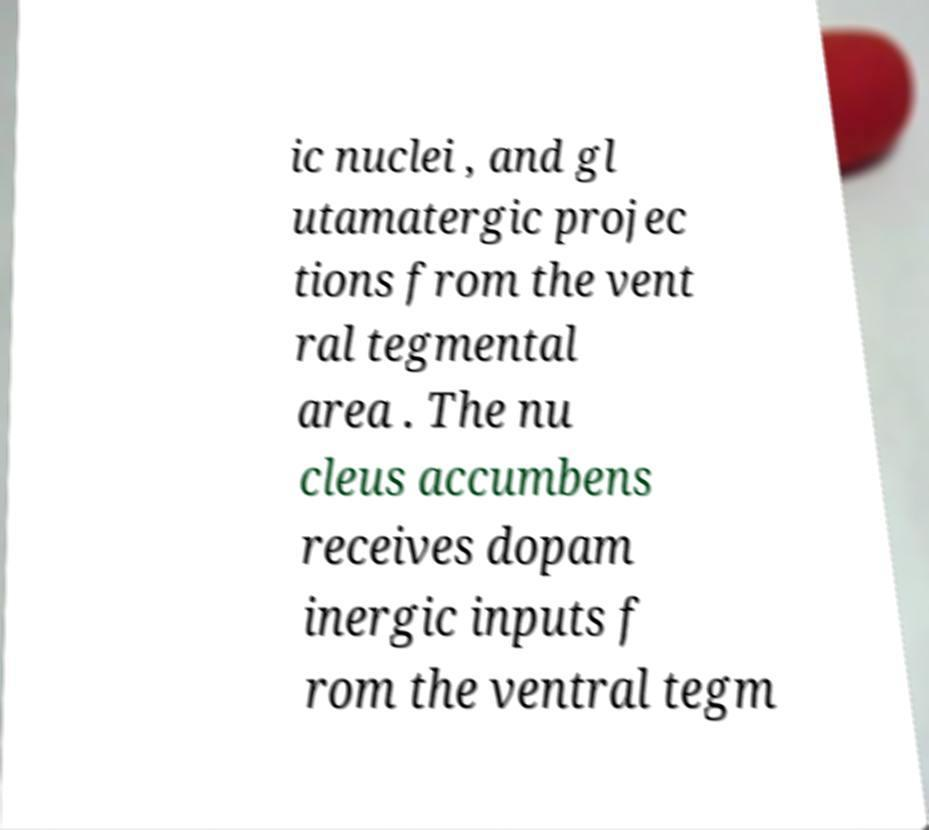Please identify and transcribe the text found in this image. ic nuclei , and gl utamatergic projec tions from the vent ral tegmental area . The nu cleus accumbens receives dopam inergic inputs f rom the ventral tegm 